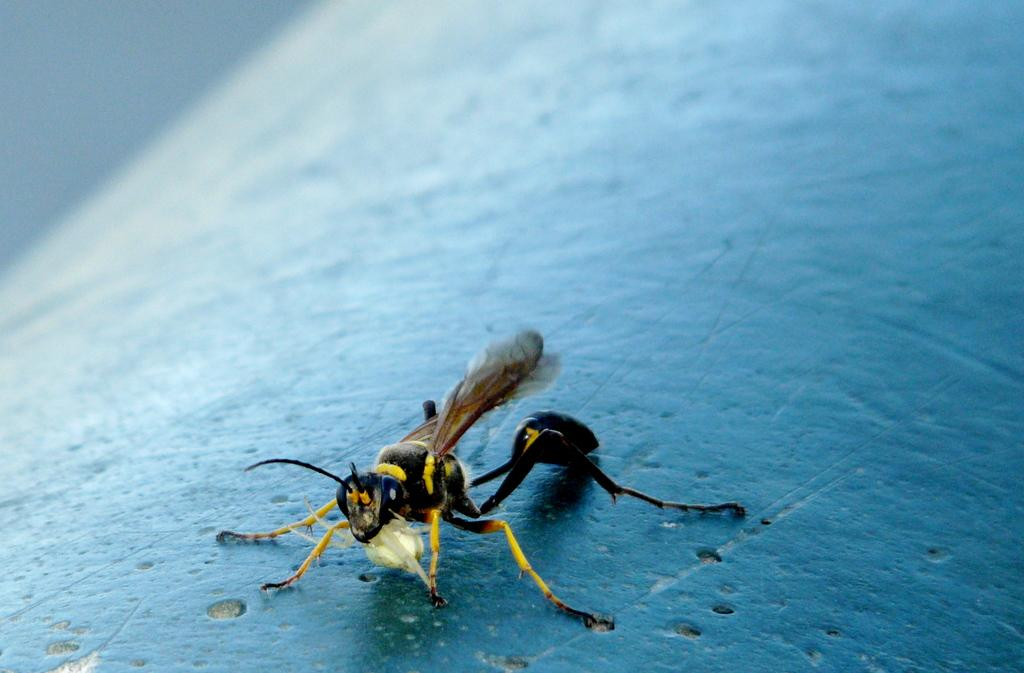What insect is present in the image? There is a wasp in the image. What color is the surface on which the wasp is resting? The wasp is on a blue surface. Can you describe the background of the image? The background of the image is blurred. What type of ink is visible in the veins of the wasp in the image? There is no ink or veins visible in the image; it is a wasp resting on a blue surface with a blurred background. 